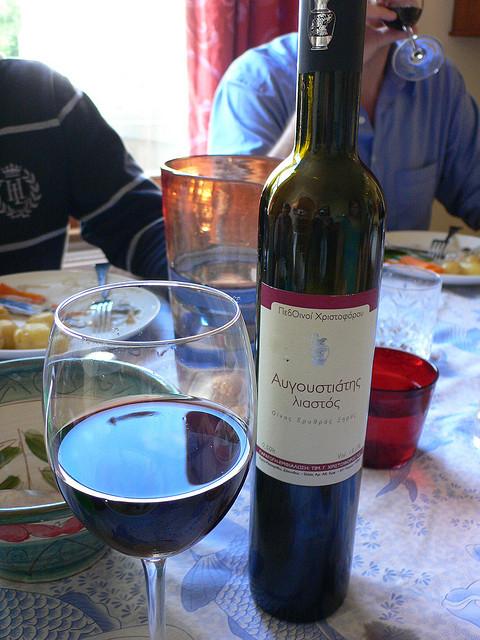Where is the window?
Answer briefly. Behind table. What is the alcohol content of this wine?
Concise answer only. 54%. What brand is wine?
Give a very brief answer. Greek. Is the red drink served in an appropriate glass?
Concise answer only. Yes. Did you try this wine?
Quick response, please. No. 